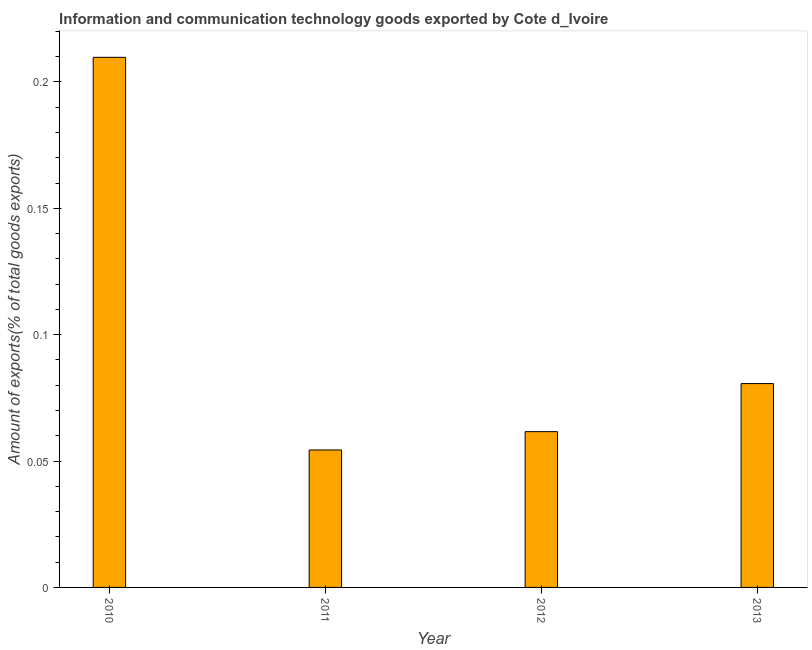What is the title of the graph?
Keep it short and to the point. Information and communication technology goods exported by Cote d_Ivoire. What is the label or title of the Y-axis?
Offer a very short reply. Amount of exports(% of total goods exports). What is the amount of ict goods exports in 2011?
Your answer should be compact. 0.05. Across all years, what is the maximum amount of ict goods exports?
Ensure brevity in your answer.  0.21. Across all years, what is the minimum amount of ict goods exports?
Ensure brevity in your answer.  0.05. In which year was the amount of ict goods exports maximum?
Your answer should be very brief. 2010. What is the sum of the amount of ict goods exports?
Keep it short and to the point. 0.41. What is the difference between the amount of ict goods exports in 2012 and 2013?
Your answer should be compact. -0.02. What is the average amount of ict goods exports per year?
Provide a succinct answer. 0.1. What is the median amount of ict goods exports?
Keep it short and to the point. 0.07. What is the ratio of the amount of ict goods exports in 2011 to that in 2012?
Provide a succinct answer. 0.88. Is the difference between the amount of ict goods exports in 2012 and 2013 greater than the difference between any two years?
Provide a short and direct response. No. What is the difference between the highest and the second highest amount of ict goods exports?
Give a very brief answer. 0.13. Is the sum of the amount of ict goods exports in 2010 and 2013 greater than the maximum amount of ict goods exports across all years?
Give a very brief answer. Yes. What is the difference between the highest and the lowest amount of ict goods exports?
Give a very brief answer. 0.16. How many bars are there?
Offer a terse response. 4. How many years are there in the graph?
Provide a succinct answer. 4. What is the Amount of exports(% of total goods exports) in 2010?
Give a very brief answer. 0.21. What is the Amount of exports(% of total goods exports) in 2011?
Make the answer very short. 0.05. What is the Amount of exports(% of total goods exports) of 2012?
Ensure brevity in your answer.  0.06. What is the Amount of exports(% of total goods exports) of 2013?
Give a very brief answer. 0.08. What is the difference between the Amount of exports(% of total goods exports) in 2010 and 2011?
Make the answer very short. 0.16. What is the difference between the Amount of exports(% of total goods exports) in 2010 and 2012?
Your answer should be compact. 0.15. What is the difference between the Amount of exports(% of total goods exports) in 2010 and 2013?
Offer a terse response. 0.13. What is the difference between the Amount of exports(% of total goods exports) in 2011 and 2012?
Make the answer very short. -0.01. What is the difference between the Amount of exports(% of total goods exports) in 2011 and 2013?
Offer a terse response. -0.03. What is the difference between the Amount of exports(% of total goods exports) in 2012 and 2013?
Keep it short and to the point. -0.02. What is the ratio of the Amount of exports(% of total goods exports) in 2010 to that in 2011?
Ensure brevity in your answer.  3.86. What is the ratio of the Amount of exports(% of total goods exports) in 2010 to that in 2012?
Give a very brief answer. 3.4. What is the ratio of the Amount of exports(% of total goods exports) in 2010 to that in 2013?
Your response must be concise. 2.6. What is the ratio of the Amount of exports(% of total goods exports) in 2011 to that in 2012?
Provide a succinct answer. 0.88. What is the ratio of the Amount of exports(% of total goods exports) in 2011 to that in 2013?
Make the answer very short. 0.67. What is the ratio of the Amount of exports(% of total goods exports) in 2012 to that in 2013?
Your answer should be compact. 0.76. 